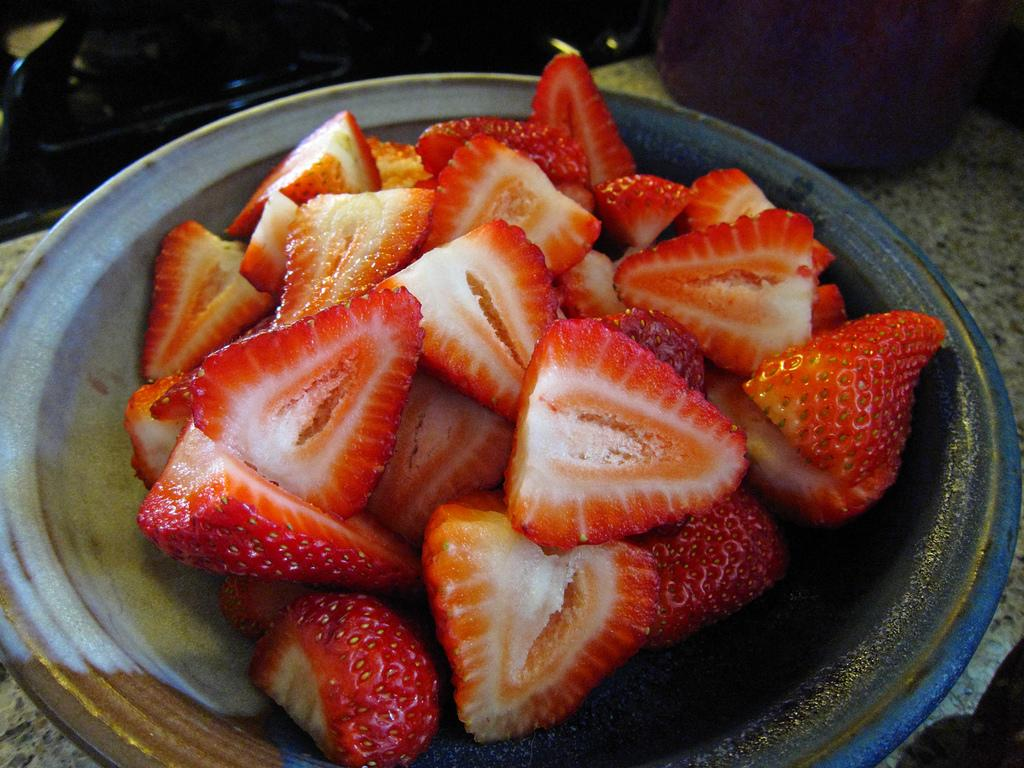What type of fruit is visible in the image? There are cut strawberries in the image. How are the strawberries arranged in the image? The strawberries are placed on a plate. Where is the plate located in the image? The plate is on a table. Can you describe the setting in the background of the image? There is a person sitting in the background of the image. What type of chickens are being transported in the image? There are no chickens or any form of transportation present in the image. 